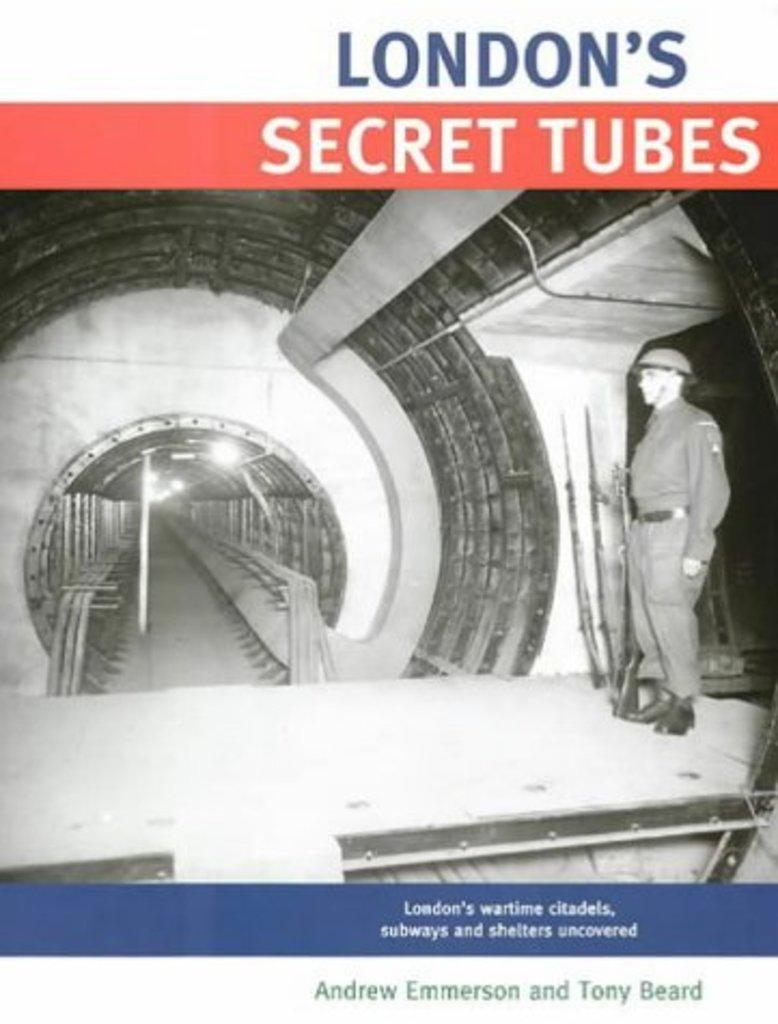What is the main object in the image? There is a paper in the image. What is depicted on the paper? A person is standing in the image, as depicted on the paper. What can be seen in the background of the image? There is a light pole in the background of the image. What is written on the paper? There is writing on the paper. How many cars are parked next to the light pole in the image? There are no cars present in the image; it only features a paper with a person standing and a light pole in the background. What type of clock is visible on the person's wrist in the image? There is no clock visible on the person's wrist in the image, as the person is depicted on the paper and not in a real-life scenario. 